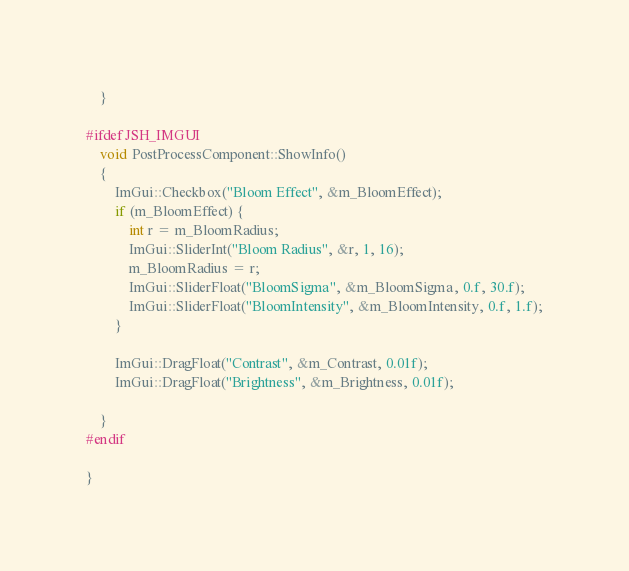<code> <loc_0><loc_0><loc_500><loc_500><_C++_>	}

#ifdef JSH_IMGUI
	void PostProcessComponent::ShowInfo()
	{
		ImGui::Checkbox("Bloom Effect", &m_BloomEffect);
		if (m_BloomEffect) {
			int r = m_BloomRadius;
			ImGui::SliderInt("Bloom Radius", &r, 1, 16);
			m_BloomRadius = r;
			ImGui::SliderFloat("BloomSigma", &m_BloomSigma, 0.f, 30.f);
			ImGui::SliderFloat("BloomIntensity", &m_BloomIntensity, 0.f, 1.f);
		}

		ImGui::DragFloat("Contrast", &m_Contrast, 0.01f);
		ImGui::DragFloat("Brightness", &m_Brightness, 0.01f);

	}
#endif

}</code> 